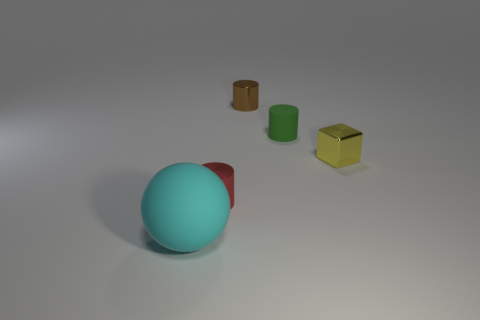Subtract all small brown metal cylinders. How many cylinders are left? 2 Add 1 big cyan balls. How many objects exist? 6 Subtract all brown cylinders. How many cylinders are left? 2 Subtract all cubes. How many objects are left? 4 Subtract 1 spheres. How many spheres are left? 0 Add 3 big yellow cubes. How many big yellow cubes exist? 3 Subtract 1 green cylinders. How many objects are left? 4 Subtract all green cubes. Subtract all blue balls. How many cubes are left? 1 Subtract all small blue blocks. Subtract all large things. How many objects are left? 4 Add 4 big cyan spheres. How many big cyan spheres are left? 5 